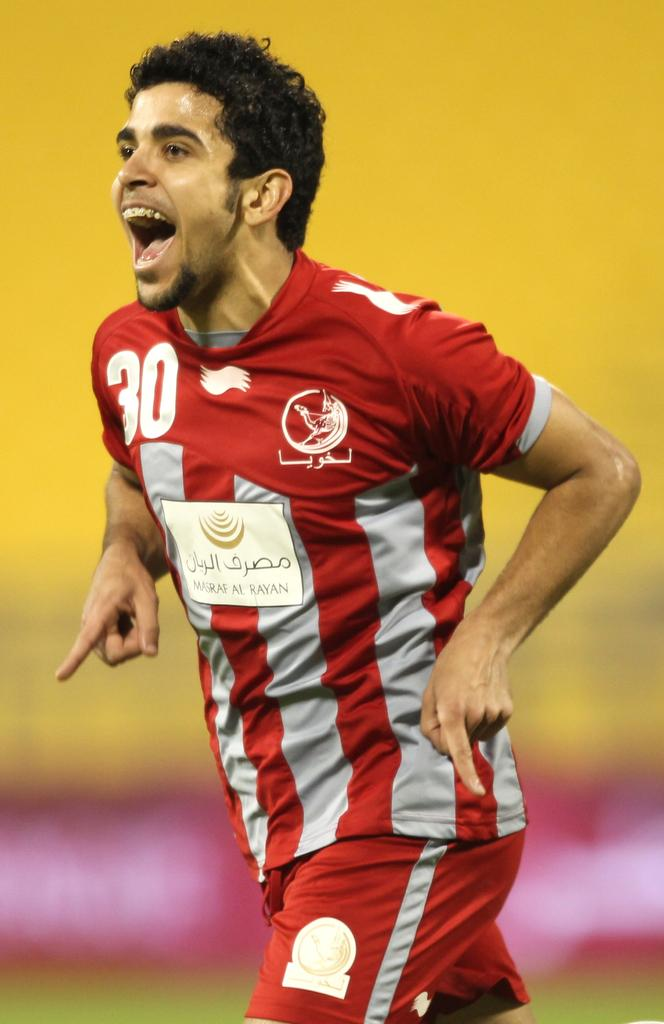<image>
Render a clear and concise summary of the photo. A guy with a red soccer outfit with the number 30 in white 